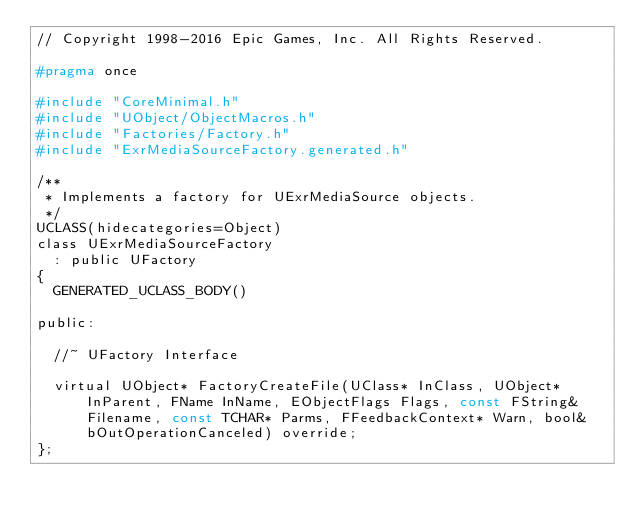Convert code to text. <code><loc_0><loc_0><loc_500><loc_500><_C_>// Copyright 1998-2016 Epic Games, Inc. All Rights Reserved.

#pragma once

#include "CoreMinimal.h"
#include "UObject/ObjectMacros.h"
#include "Factories/Factory.h"
#include "ExrMediaSourceFactory.generated.h"

/**
 * Implements a factory for UExrMediaSource objects.
 */
UCLASS(hidecategories=Object)
class UExrMediaSourceFactory
	: public UFactory
{
	GENERATED_UCLASS_BODY()

public:

	//~ UFactory Interface

	virtual UObject* FactoryCreateFile(UClass* InClass, UObject* InParent, FName InName, EObjectFlags Flags, const FString& Filename, const TCHAR* Parms, FFeedbackContext* Warn, bool& bOutOperationCanceled) override;
};
</code> 